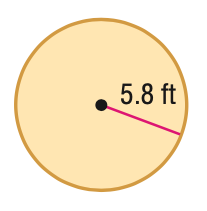Question: Find the area of the figure. Round to the nearest tenth.
Choices:
A. 36.4
B. 105.7
C. 211.4
D. 422.7
Answer with the letter. Answer: B 